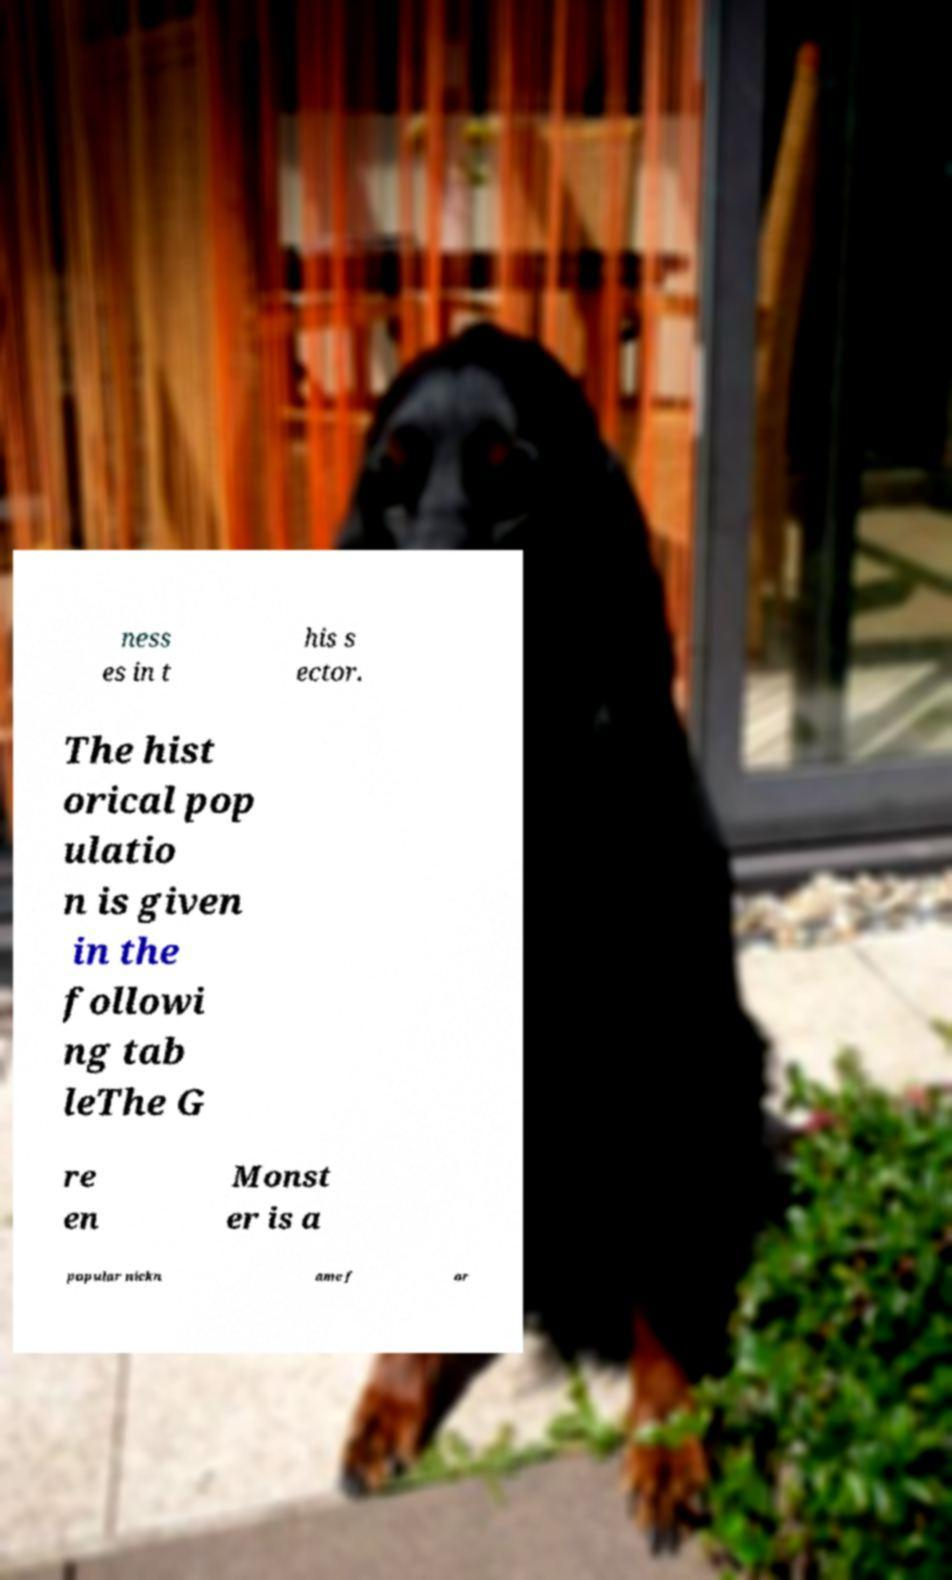Can you accurately transcribe the text from the provided image for me? ness es in t his s ector. The hist orical pop ulatio n is given in the followi ng tab leThe G re en Monst er is a popular nickn ame f or 